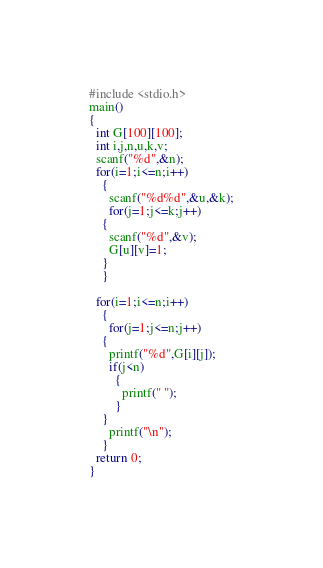Convert code to text. <code><loc_0><loc_0><loc_500><loc_500><_C_>#include <stdio.h>
main()
{
  int G[100][100];
  int i,j,n,u,k,v;
  scanf("%d",&n);
  for(i=1;i<=n;i++)
    {
      scanf("%d%d",&u,&k);
      for(j=1;j<=k;j++)
	{
	  scanf("%d",&v);
	  G[u][v]=1;	
	}
    }

  for(i=1;i<=n;i++)
    {
      for(j=1;j<=n;j++)
	{
	  printf("%d",G[i][j]);
	  if(j<n)
	    {
	      printf(" ");
	    }
	}
      printf("\n");
    }
  return 0;
}</code> 